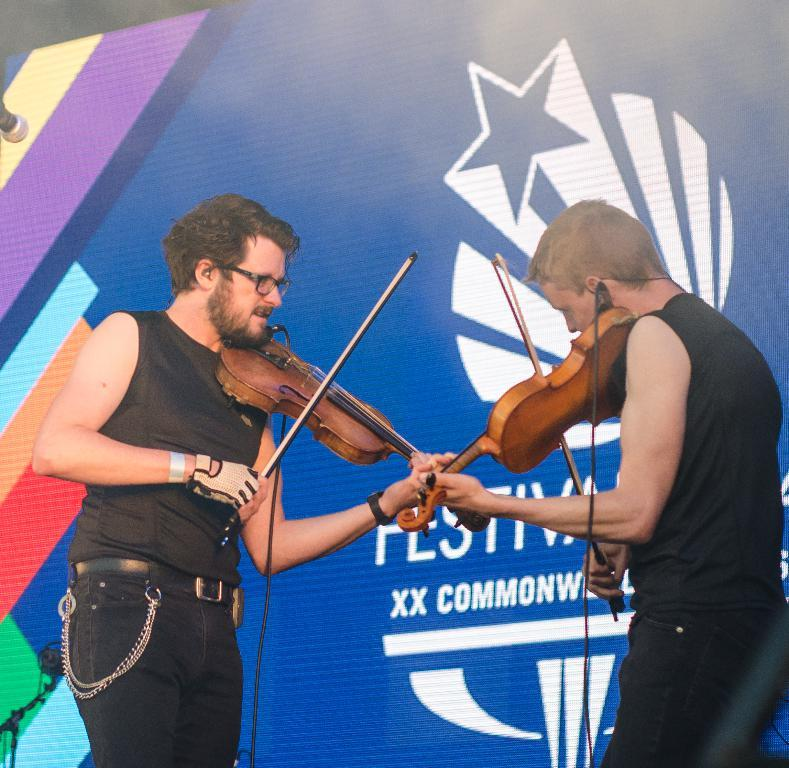How many people are in the image? There are two men in the image. What are the men doing in the image? The men are playing a violin. What are the men wearing in the image? The men are wearing black costumes. What can be seen in the background of the image? There is a banner in the image, which displays a logo for a festival. Can you see any office supplies on the table in the image? There is no table or office supplies present in the image. What type of window can be seen in the image? There is no window present in the image. 